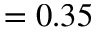<formula> <loc_0><loc_0><loc_500><loc_500>= 0 . 3 5</formula> 